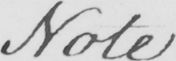Can you tell me what this handwritten text says? Note 